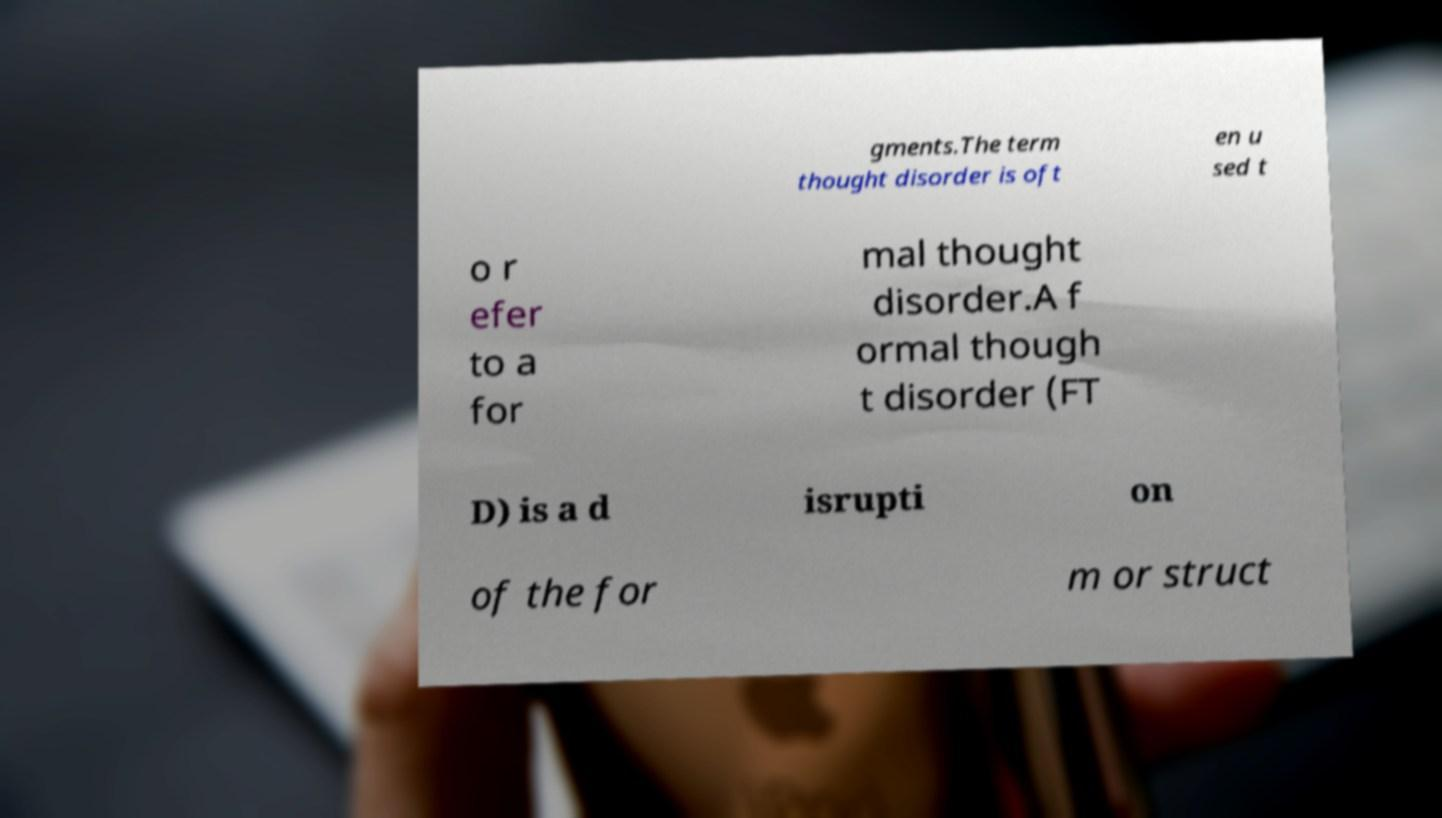Please read and relay the text visible in this image. What does it say? gments.The term thought disorder is oft en u sed t o r efer to a for mal thought disorder.A f ormal though t disorder (FT D) is a d isrupti on of the for m or struct 